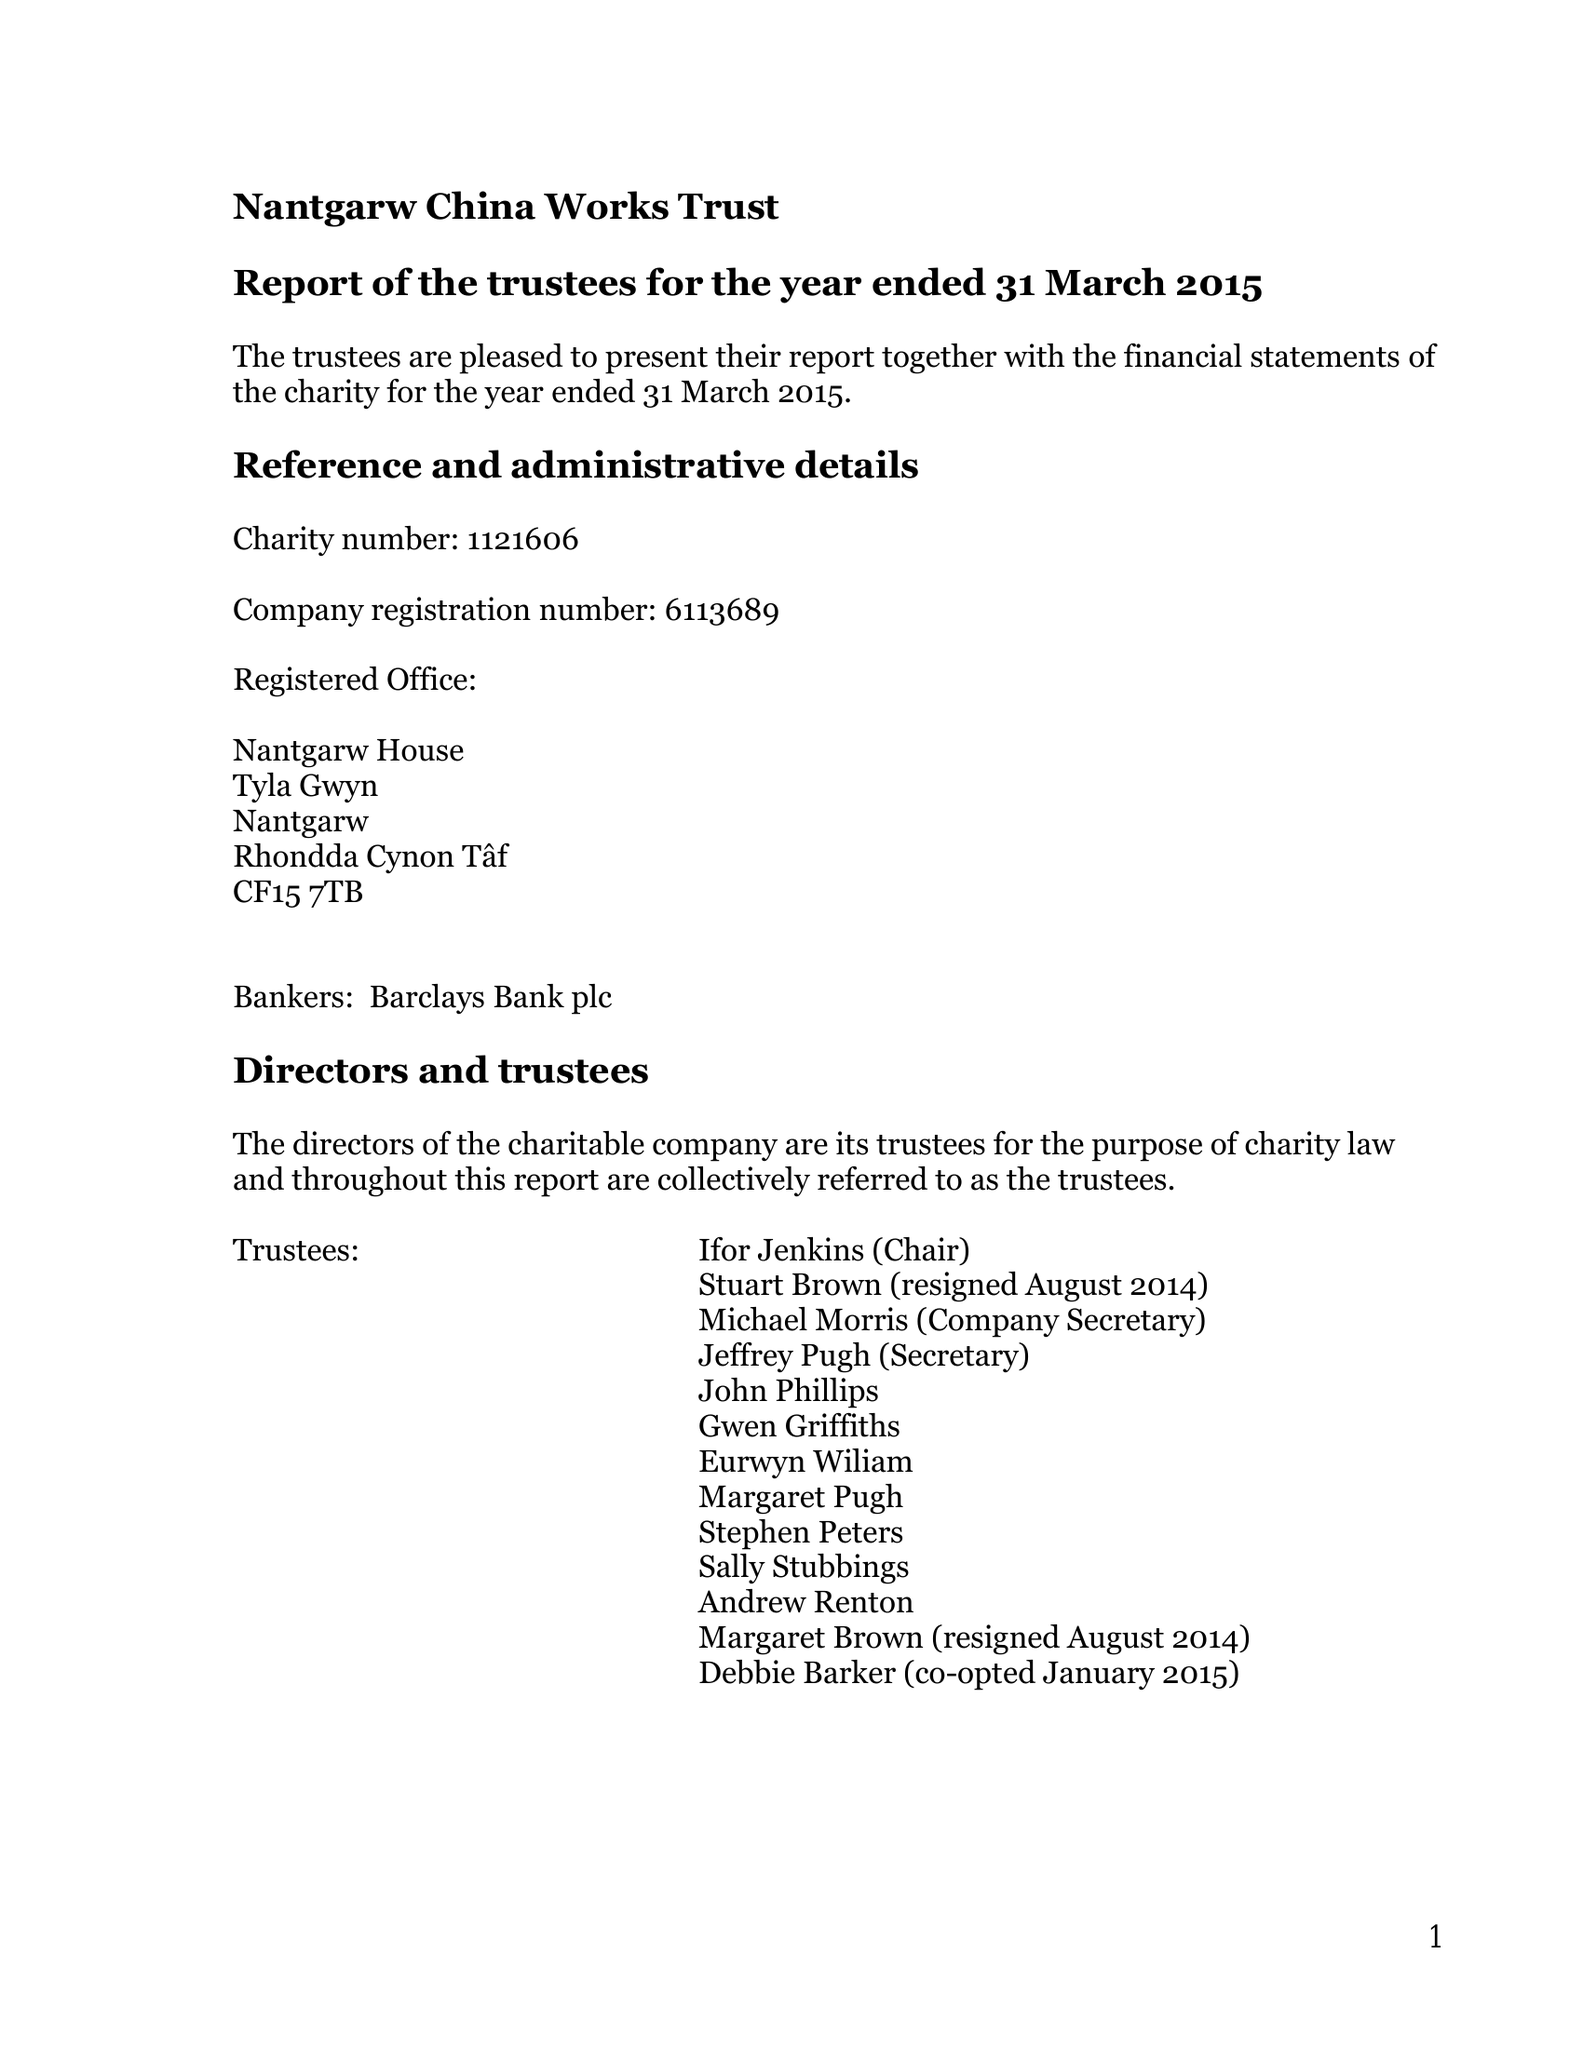What is the value for the charity_number?
Answer the question using a single word or phrase. 1121606 